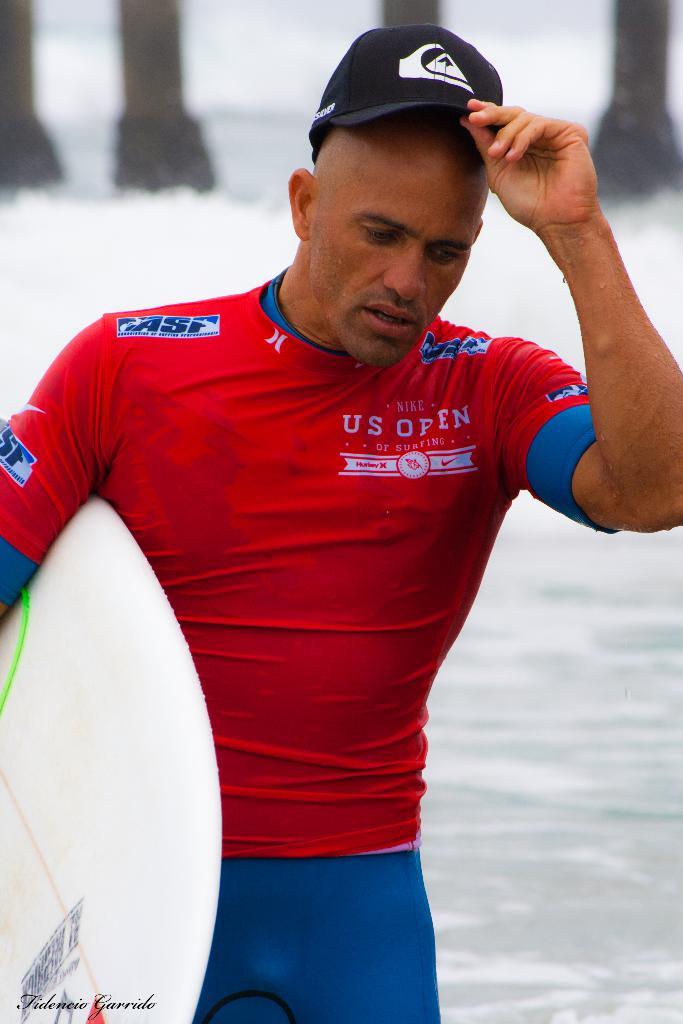Who is sponsoring him?
Provide a succinct answer. Asf. What sport is he participating in?
Offer a very short reply. Surfing. 